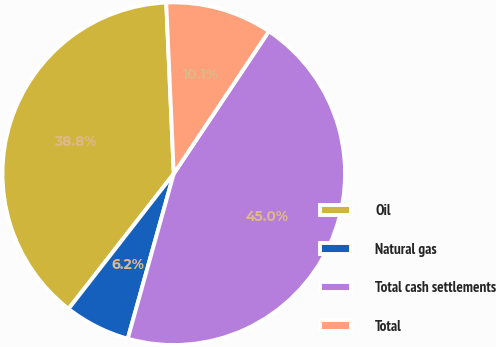<chart> <loc_0><loc_0><loc_500><loc_500><pie_chart><fcel>Oil<fcel>Natural gas<fcel>Total cash settlements<fcel>Total<nl><fcel>38.77%<fcel>6.2%<fcel>44.96%<fcel>10.07%<nl></chart> 